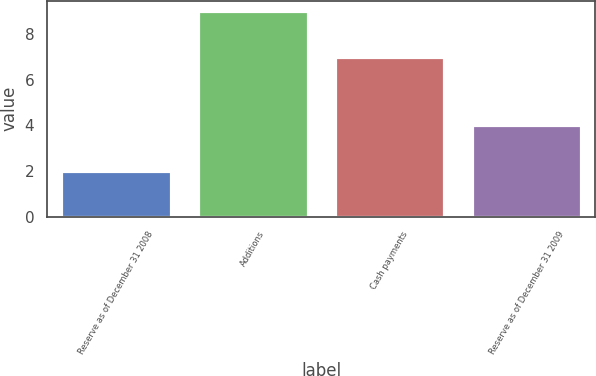Convert chart. <chart><loc_0><loc_0><loc_500><loc_500><bar_chart><fcel>Reserve as of December 31 2008<fcel>Additions<fcel>Cash payments<fcel>Reserve as of December 31 2009<nl><fcel>2<fcel>9<fcel>7<fcel>4<nl></chart> 